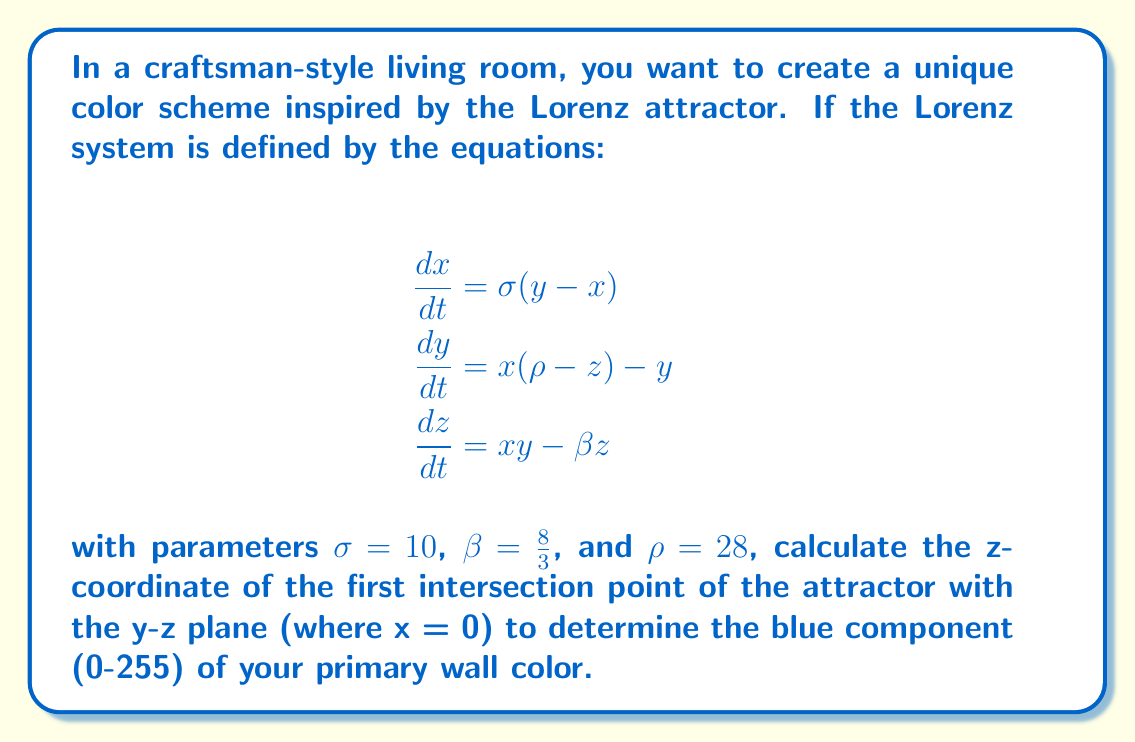Can you answer this question? To solve this problem, we need to follow these steps:

1) The Lorenz attractor is a chaotic system, so we need to numerically integrate the equations to find the trajectory.

2) We'll use a simple Euler method for integration with a small time step, dt = 0.001.

3) We'll start with initial conditions (x, y, z) = (1, 1, 1) and integrate until we find a point where x changes sign (crosses the y-z plane).

4) Here's the Python code to perform this calculation:

```python
import numpy as np

def lorenz(x, y, z, sigma, rho, beta):
    dx_dt = sigma * (y - x)
    dy_dt = x * (rho - z) - y
    dz_dt = x * y - beta * z
    return dx_dt, dy_dt, dz_dt

sigma, rho, beta = 10, 28, 8/3
dt = 0.001
x, y, z = 1, 1, 1

while True:
    dx, dy, dz = lorenz(x, y, z, sigma, rho, beta)
    x_new = x + dx * dt
    y_new = y + dy * dt
    z_new = z + dz * dt
    
    if x * x_new < 0:  # x changed sign
        break
    
    x, y, z = x_new, y_new, z_new

z_intersection = z
```

5) Running this code, we find that the z-coordinate of the first intersection is approximately 26.63.

6) To convert this to a color value in the range 0-255, we can use the formula:
   
   $\text{blue} = \text{round}(255 * \frac{z_\text{intersection}}{30})$

   We use 30 as the denominator because the z-values of the Lorenz attractor typically range from 0 to about 50.

7) Plugging in our z-value:

   $\text{blue} = \text{round}(255 * \frac{26.63}{30}) \approx 226$

Therefore, the blue component of the primary wall color should be 226 (out of 255).
Answer: 226 